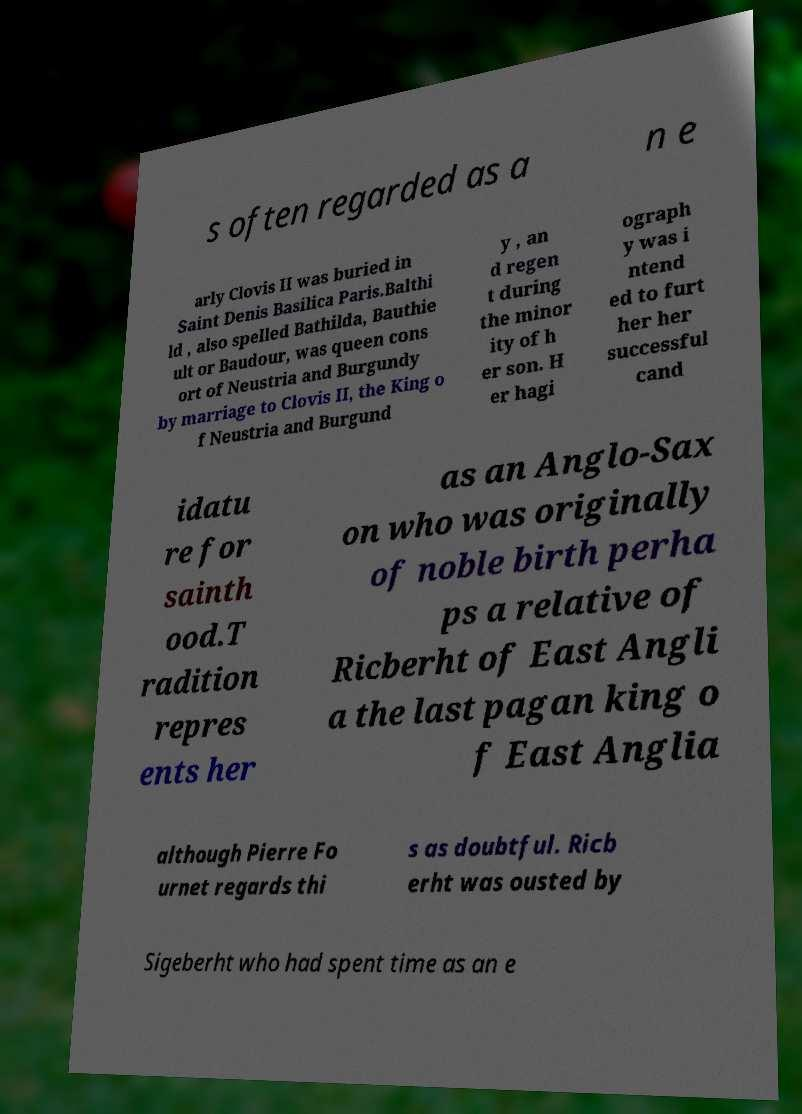I need the written content from this picture converted into text. Can you do that? s often regarded as a n e arly Clovis II was buried in Saint Denis Basilica Paris.Balthi ld , also spelled Bathilda, Bauthie ult or Baudour, was queen cons ort of Neustria and Burgundy by marriage to Clovis II, the King o f Neustria and Burgund y , an d regen t during the minor ity of h er son. H er hagi ograph y was i ntend ed to furt her her successful cand idatu re for sainth ood.T radition repres ents her as an Anglo-Sax on who was originally of noble birth perha ps a relative of Ricberht of East Angli a the last pagan king o f East Anglia although Pierre Fo urnet regards thi s as doubtful. Ricb erht was ousted by Sigeberht who had spent time as an e 